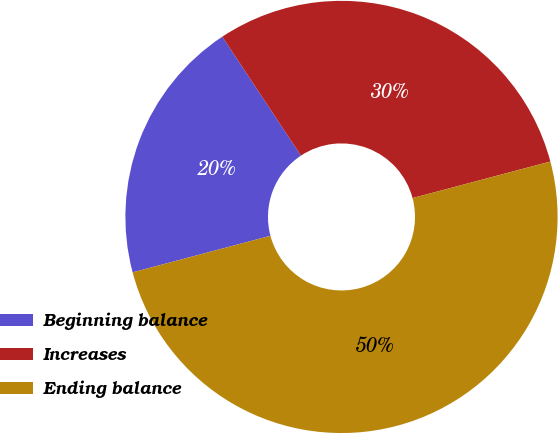<chart> <loc_0><loc_0><loc_500><loc_500><pie_chart><fcel>Beginning balance<fcel>Increases<fcel>Ending balance<nl><fcel>19.83%<fcel>30.17%<fcel>50.0%<nl></chart> 